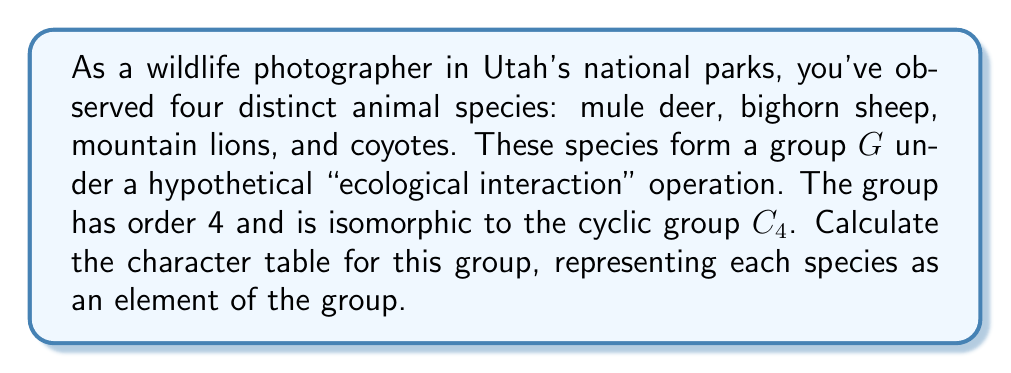Can you solve this math problem? Let's approach this step-by-step:

1) First, we need to identify the elements of the group $G$. Let's assign:
   $e$ = mule deer (identity element)
   $a$ = bighorn sheep
   $a^2$ = mountain lion
   $a^3$ = coyote

2) The group $G$ is isomorphic to $C_4$, so it has the following conjugacy classes:
   $\{e\}$, $\{a, a^3\}$, $\{a^2\}$

3) The number of irreducible representations is equal to the number of conjugacy classes, which is 3.

4) For a cyclic group of order 4, the irreducible representations are:
   $\chi_0(a^k) = 1$ for all $k$
   $\chi_1(a^k) = i^k$
   $\chi_2(a^k) = (-1)^k$
   $\chi_3(a^k) = (-i)^k$

5) Now, we can construct the character table:

   $$\begin{array}{c|cccc}
      G & e & a & a^2 & a^3 \\
      \hline
      \chi_0 & 1 & 1 & 1 & 1 \\
      \chi_1 & 1 & i & -1 & -i \\
      \chi_2 & 1 & -1 & 1 & -1 \\
      \chi_3 & 1 & -i & -1 & i
   \end{array}$$

6) Translating back to our animal species:

   $$\begin{array}{c|cccc}
      G & \text{Mule Deer} & \text{Bighorn Sheep} & \text{Mountain Lion} & \text{Coyote} \\
      \hline
      \chi_0 & 1 & 1 & 1 & 1 \\
      \chi_1 & 1 & i & -1 & -i \\
      \chi_2 & 1 & -1 & 1 & -1 \\
      \chi_3 & 1 & -i & -1 & i
   \end{array}$$

This character table represents the irreducible representations of our group of animal species under the hypothetical "ecological interaction" operation.
Answer: $$\begin{array}{c|cccc}
   G & \text{Mule Deer} & \text{Bighorn Sheep} & \text{Mountain Lion} & \text{Coyote} \\
   \hline
   \chi_0 & 1 & 1 & 1 & 1 \\
   \chi_1 & 1 & i & -1 & -i \\
   \chi_2 & 1 & -1 & 1 & -1 \\
   \chi_3 & 1 & -i & -1 & i
\end{array}$$ 